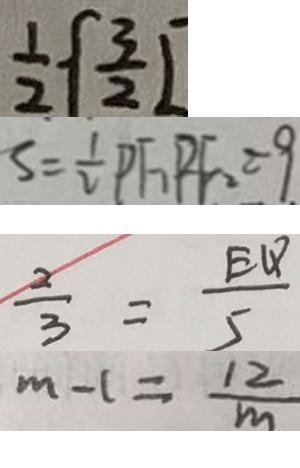<formula> <loc_0><loc_0><loc_500><loc_500>\frac { 1 } { 2 } \{ \frac { 3 } { 2 } L 
 S = \frac { 1 } { 2 } P F _ { 1 } P F _ { 2 } = 9 
 \frac { 2 } { 3 } = \frac { E Q } { 5 } 
 m - 1 = \frac { 1 2 } { m }</formula> 